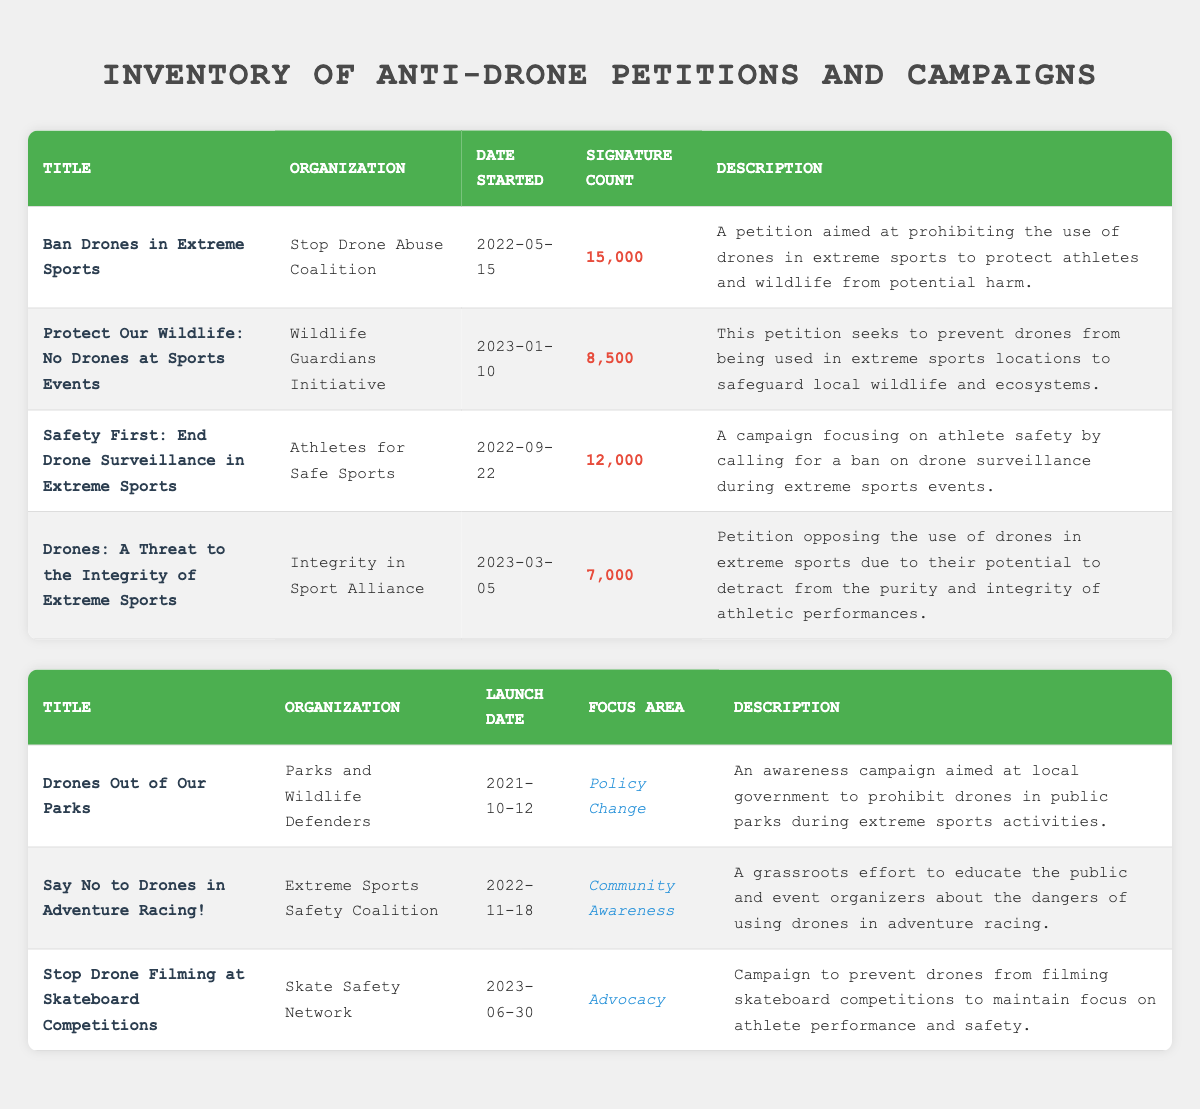What is the title of the petition with the highest signature count? The petition titled "Ban Drones in Extreme Sports" has the highest signature count of 15,000, as seen in the table.
Answer: Ban Drones in Extreme Sports How many signatures does the petition "Drones: A Threat to the Integrity of Extreme Sports" have? The petition "Drones: A Threat to the Integrity of Extreme Sports" has 7,000 signatures according to the signature count column in the table.
Answer: 7,000 Which organization launched the campaign "Say No to Drones in Adventure Racing!"? The organization that launched the campaign "Say No to Drones in Adventure Racing!" is the Extreme Sports Safety Coalition, as this information is provided in the organization column of the table.
Answer: Extreme Sports Safety Coalition What is the average number of signatures for the petitions listed? To find the average, sum the signature counts (15,000 + 8,500 + 12,000 + 7,000 = 42,500), then divide by the number of petitions (4). Thus, the average is 42,500 / 4 = 10,625.
Answer: 10,625 Is there a campaign that focuses on community awareness? Yes, the campaign titled "Say No to Drones in Adventure Racing!" focuses on community awareness, as indicated in the focus area column.
Answer: Yes Which petition was started most recently? The most recently started petition is "Protect Our Wildlife: No Drones at Sports Events," which began on January 10, 2023, determined by comparing the dates in the table.
Answer: Protect Our Wildlife: No Drones at Sports Events How many campaigns are focused on advocacy? There is one campaign focused on advocacy, which is "Stop Drone Filming at Skateboard Competitions," identifiable from the focus area column in the table.
Answer: 1 Which organization has the most campaigns listed? The organization with the most campaigns listed is "Skate Safety Network," as it is associated with a single campaign according to the data.
Answer: Skate Safety Network 